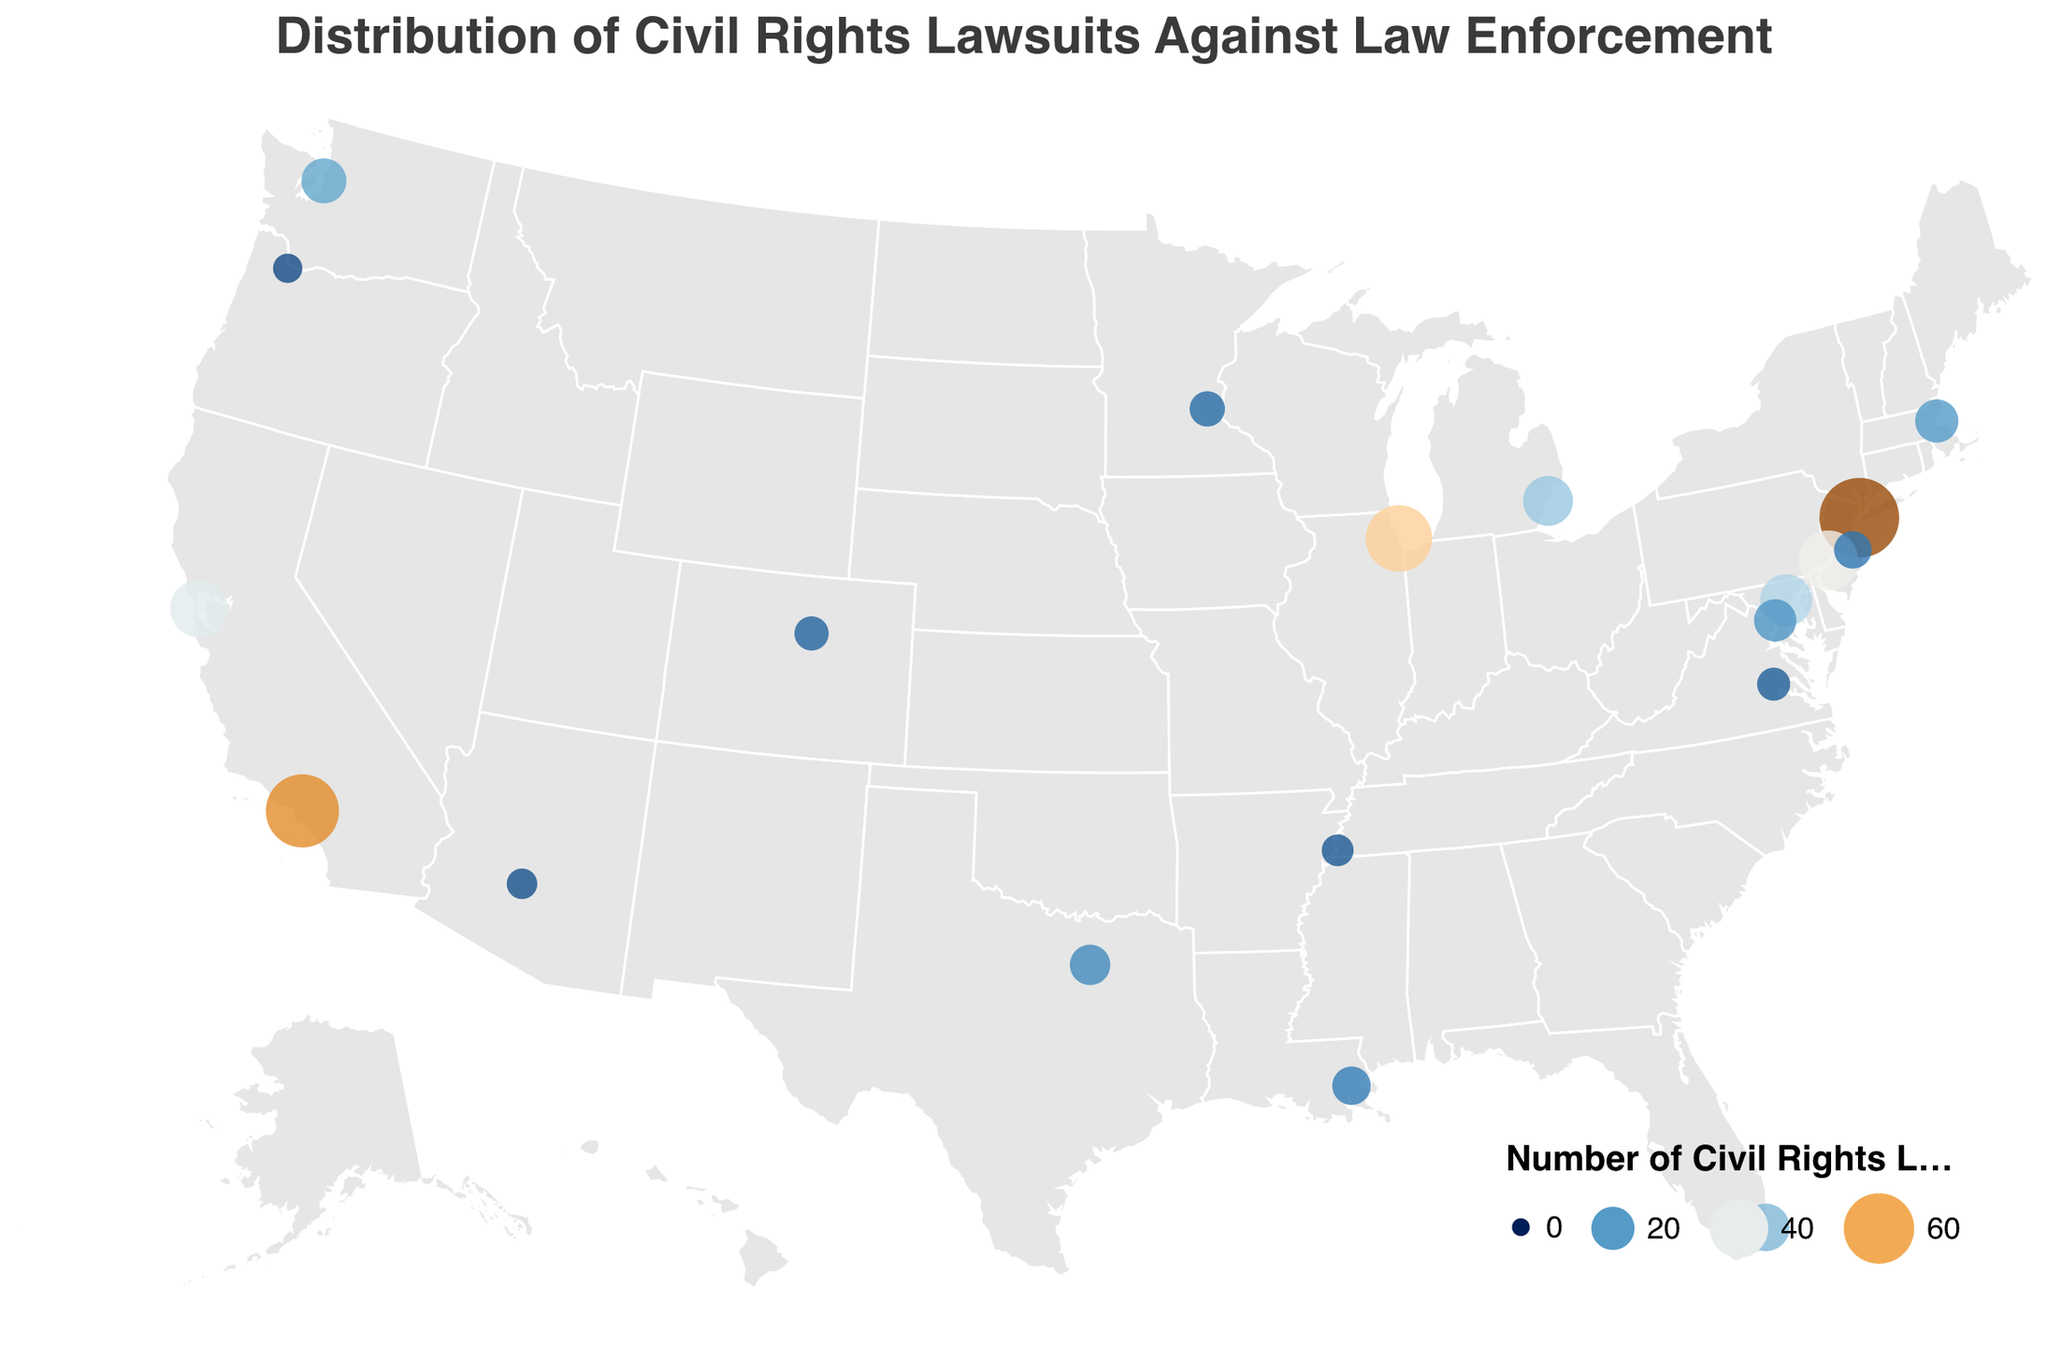What is the title of the figure? The title of the figure is typically found at the top of the chart and provides a general description of what the visualization is about. In this case, it is labeled as "Distribution of Civil Rights Lawsuits Against Law Enforcement".
Answer: Distribution of Civil Rights Lawsuits Against Law Enforcement Which court district has the highest number of civil rights lawsuits filed against it? The size and color of the circles indicate the number of civil rights lawsuits. The Southern District of New York has the largest circle which corresponds to the highest number, 78.
Answer: Southern District of New York How many civil rights lawsuits have been filed in the Central District of California? By locating the Central District of California on the map, we see the corresponding circle's tooltip indicates 65 lawsuits.
Answer: 65 What court district has the lowest number of civil rights lawsuits and how many were filed there? We look for the smallest circle on the map, which represents the lowest number of lawsuits. The tooltip indicates that the District of Oregon has 7 lawsuits, the lowest number.
Answer: District of Oregon, 7 Compare the number of civil rights lawsuits in the Northern District of Illinois and the Northern District of California. Which has more, and by how much? By hovering over the circles for these districts, the Northern District of Illinois has 53 lawsuits, while the Northern District of California has 39. Therefore, the Northern District of Illinois has 53 - 39 = 14 more lawsuits.
Answer: Northern District of Illinois, by 14 What is the average number of civil rights lawsuits across all the districts shown? To calculate the average, sum all the lawsuits: 78 + 65 + 53 + 42 + 39 + 31 + 28 + 25 + 22 + 20 + 19 + 17 + 15 + 14 + 12 + 11 + 10 + 9 + 8 + 7 = 525. There are 20 districts, so the average is 525/20 = 26.25.
Answer: 26.25 How many districts have more than 20 lawsuits filed against them? By checking each district's circle, we count those with more than 20 lawsuits: Southern District of New York (78), Central District of California (65), Northern District of Illinois (53), Eastern District of Pennsylvania (42), Northern District of California (39), District of Maryland (31), Eastern District of Michigan (28), Southern District of Florida (25), Western District of Washington (22). So, there are 9 districts.
Answer: 9 Which court districts are represented in states on the East Coast, and how many lawsuits have been filed in each of those districts? The Eastern Coast districts are: Southern District of New York (78), Eastern District of Pennsylvania (42), District of Maryland (31), Southern District of Florida (25), and District of Massachusetts (20).
Answer: Southern District of New York - 78, Eastern District of Pennsylvania - 42, District of Maryland - 31, Southern District of Florida - 25, District of Massachusetts - 20 What federal court district has the second-highest number of lawsuits and where is it located? The circles display increasing size with an increasing number of lawsuits. The second-largest circle corresponds to the Central District of California with 65 lawsuits.
Answer: Central District of California, located in Los Angeles (approximately) Calculate the total number of lawsuits filed in the West Coast districts. The West Coast districts are: Northern District of California (39), Central District of California (65), Western District of Washington (22), and District of Oregon (7). Summing them up: 39 + 65 + 22 + 7 = 133.
Answer: 133 